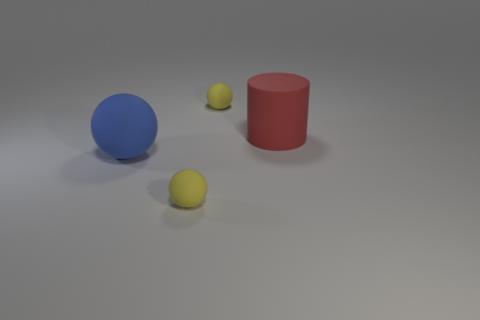What shape is the yellow rubber object that is left of the yellow thing behind the red object that is on the right side of the large blue sphere?
Keep it short and to the point. Sphere. What is the shape of the large rubber object that is on the right side of the blue rubber thing?
Your answer should be very brief. Cylinder. How many other things are there of the same shape as the blue matte thing?
Offer a terse response. 2. What is the shape of the small yellow rubber thing in front of the big rubber thing in front of the big cylinder?
Provide a succinct answer. Sphere. Is the shape of the thing that is behind the large red cylinder the same as  the big red matte object?
Offer a very short reply. No. Are there more blue matte balls that are on the right side of the large blue sphere than big rubber cylinders right of the red matte cylinder?
Provide a short and direct response. No. How many large blue matte spheres are in front of the sphere in front of the blue rubber sphere?
Offer a terse response. 0. What number of other things are the same color as the big matte cylinder?
Your response must be concise. 0. What color is the small rubber thing that is to the right of the yellow thing in front of the cylinder?
Offer a terse response. Yellow. What number of matte objects are either yellow balls or red things?
Keep it short and to the point. 3. 